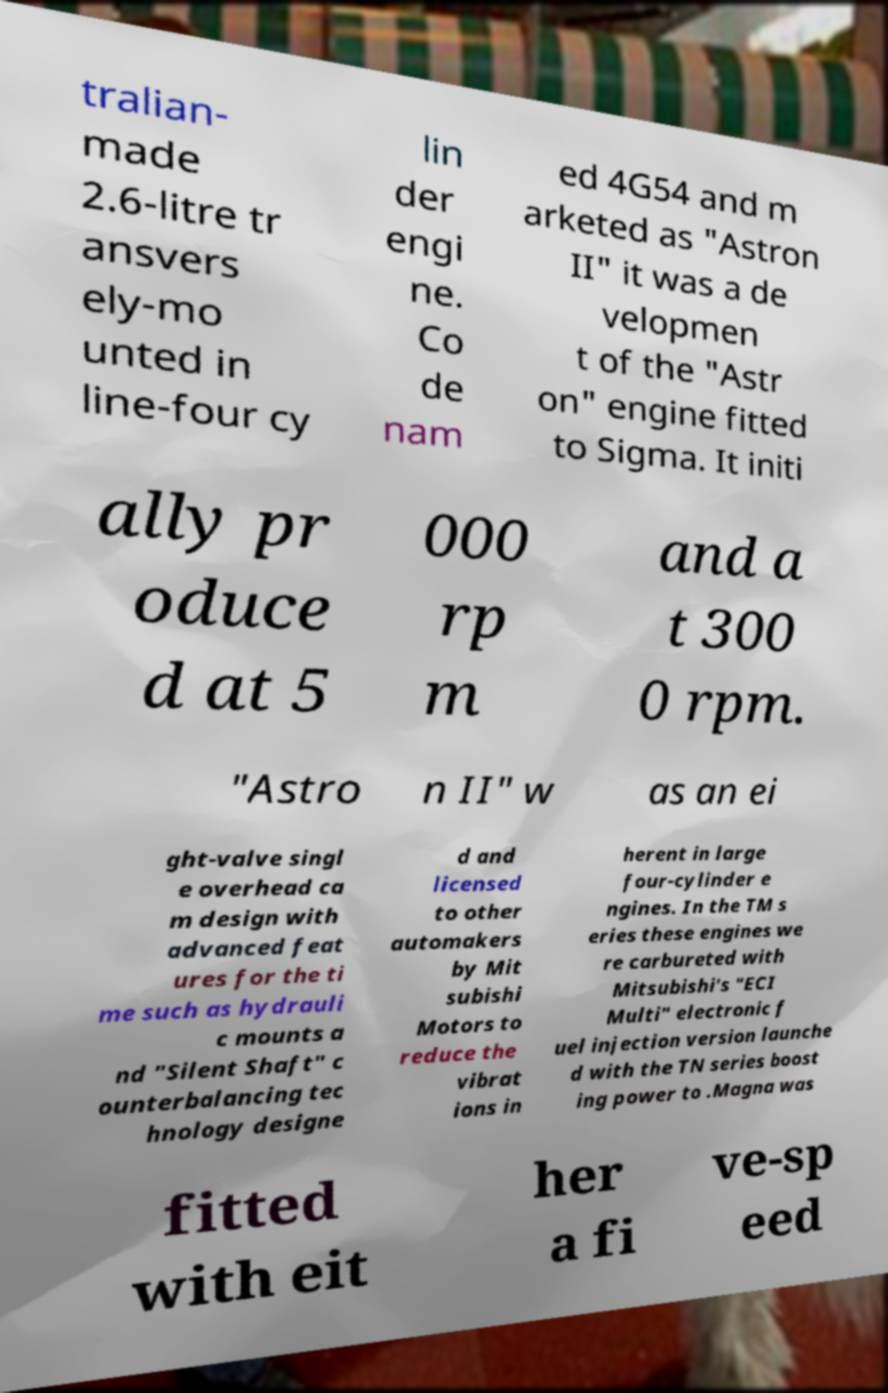Can you accurately transcribe the text from the provided image for me? tralian- made 2.6-litre tr ansvers ely-mo unted in line-four cy lin der engi ne. Co de nam ed 4G54 and m arketed as "Astron II" it was a de velopmen t of the "Astr on" engine fitted to Sigma. It initi ally pr oduce d at 5 000 rp m and a t 300 0 rpm. "Astro n II" w as an ei ght-valve singl e overhead ca m design with advanced feat ures for the ti me such as hydrauli c mounts a nd "Silent Shaft" c ounterbalancing tec hnology designe d and licensed to other automakers by Mit subishi Motors to reduce the vibrat ions in herent in large four-cylinder e ngines. In the TM s eries these engines we re carbureted with Mitsubishi's "ECI Multi" electronic f uel injection version launche d with the TN series boost ing power to .Magna was fitted with eit her a fi ve-sp eed 